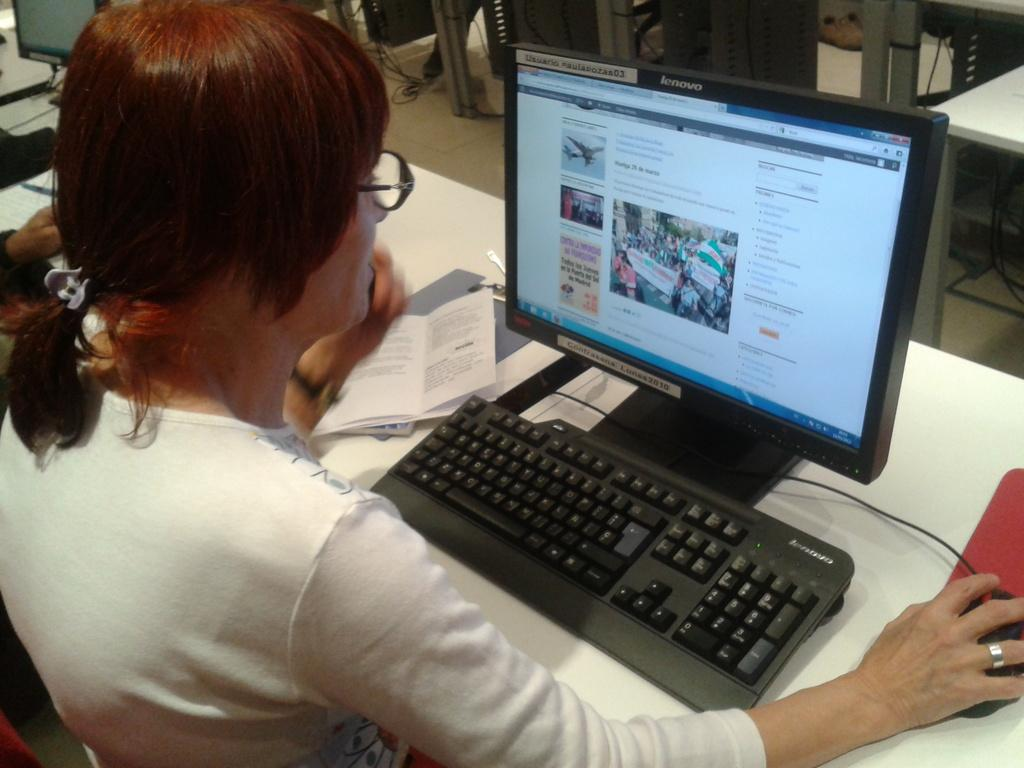Who is the main subject in the image? There is a lady in the image. What is the lady doing in the image? The lady is sitting in front of a table and operating a system. What can be seen on or near the table? There is a book on or near the table. How many tables are visible in the image? There are other tables in the image. What other objects or elements can be seen in the image? There are other objects or elements in the image. What type of beast is present in the image? There is no beast present in the image. What is the lady's belief about the bell in the image? There is no bell present in the image, so it is not possible to determine the lady's belief about it. 